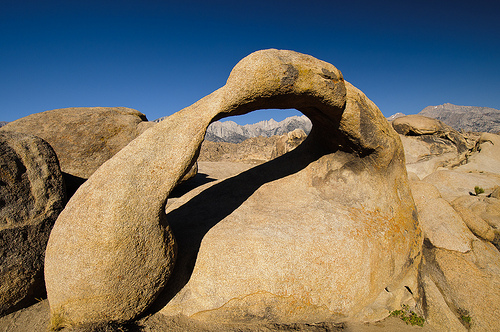<image>
Is the rock under the shadow? Yes. The rock is positioned underneath the shadow, with the shadow above it in the vertical space. 